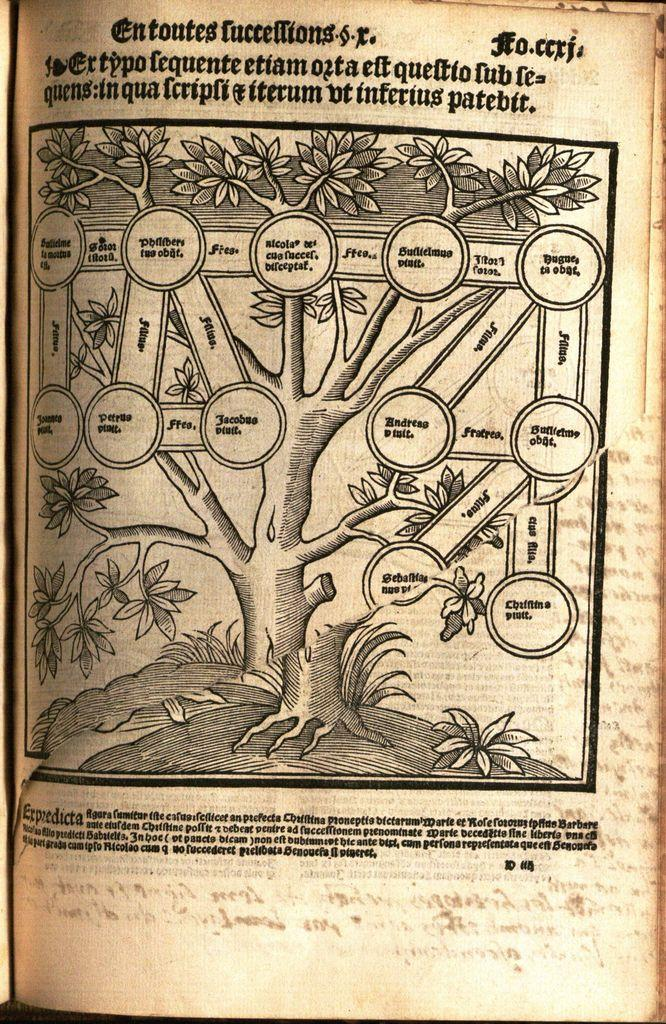What is the main object in the picture? There is a book in the picture. What is depicted in the book? The book contains a drawing of a tree. Where can text be found in the book? There is text at the bottom and top of the book. What else is present in the picture besides the book? There is a flowchart in the center of the picture. What type of sticks are used to draw the tree in the book? There is no mention of sticks being used to draw the tree in the book; it is a drawing created with a pen, pencil, or other drawing tool. 